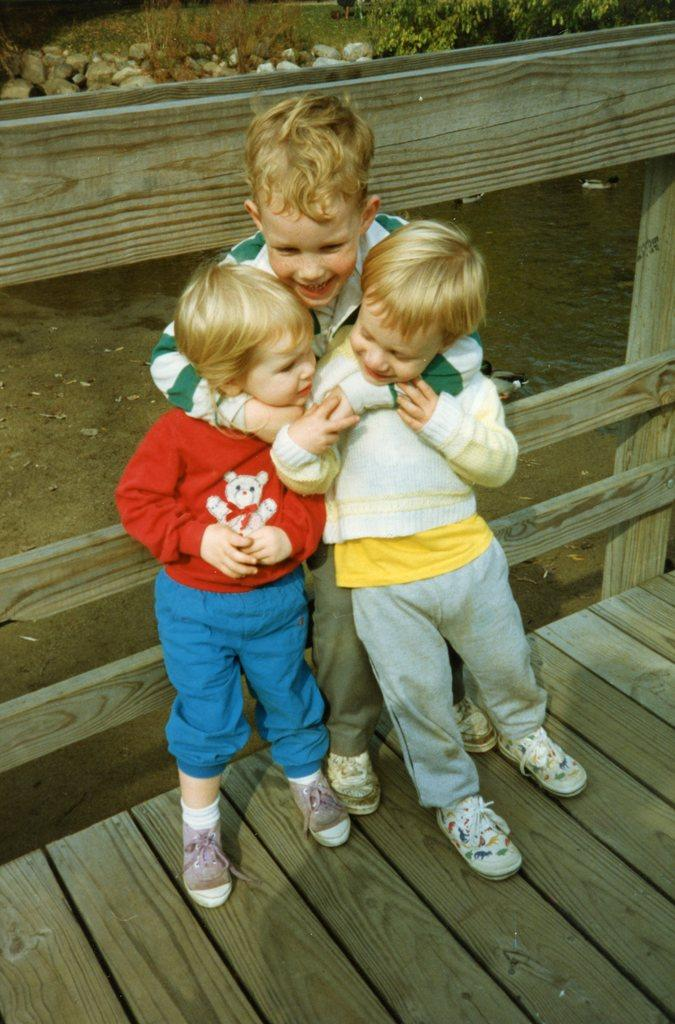How many kids are in the image? There are three kids in the image. What surface are the kids standing on? The kids are standing on a wooden surface. What is behind the kids in the image? There is a wooden railing behind the kids. What can be seen in the background of the image? There is a water surface, stones, and plants visible in the background of the image. What type of self-driving vehicle can be seen in the image? There is no self-driving vehicle present in the image. How do the cows start their day in the image? There are no cows present in the image. 